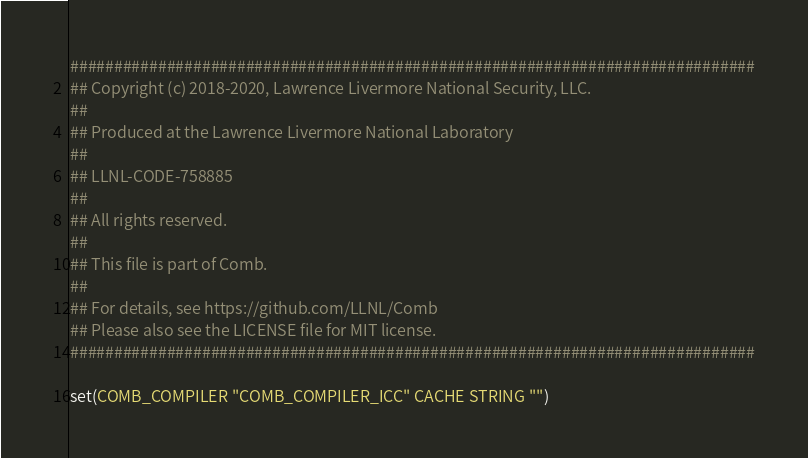<code> <loc_0><loc_0><loc_500><loc_500><_CMake_>##############################################################################
## Copyright (c) 2018-2020, Lawrence Livermore National Security, LLC.
##
## Produced at the Lawrence Livermore National Laboratory
##
## LLNL-CODE-758885
##
## All rights reserved.
##
## This file is part of Comb.
##
## For details, see https://github.com/LLNL/Comb
## Please also see the LICENSE file for MIT license.
##############################################################################

set(COMB_COMPILER "COMB_COMPILER_ICC" CACHE STRING "")
</code> 